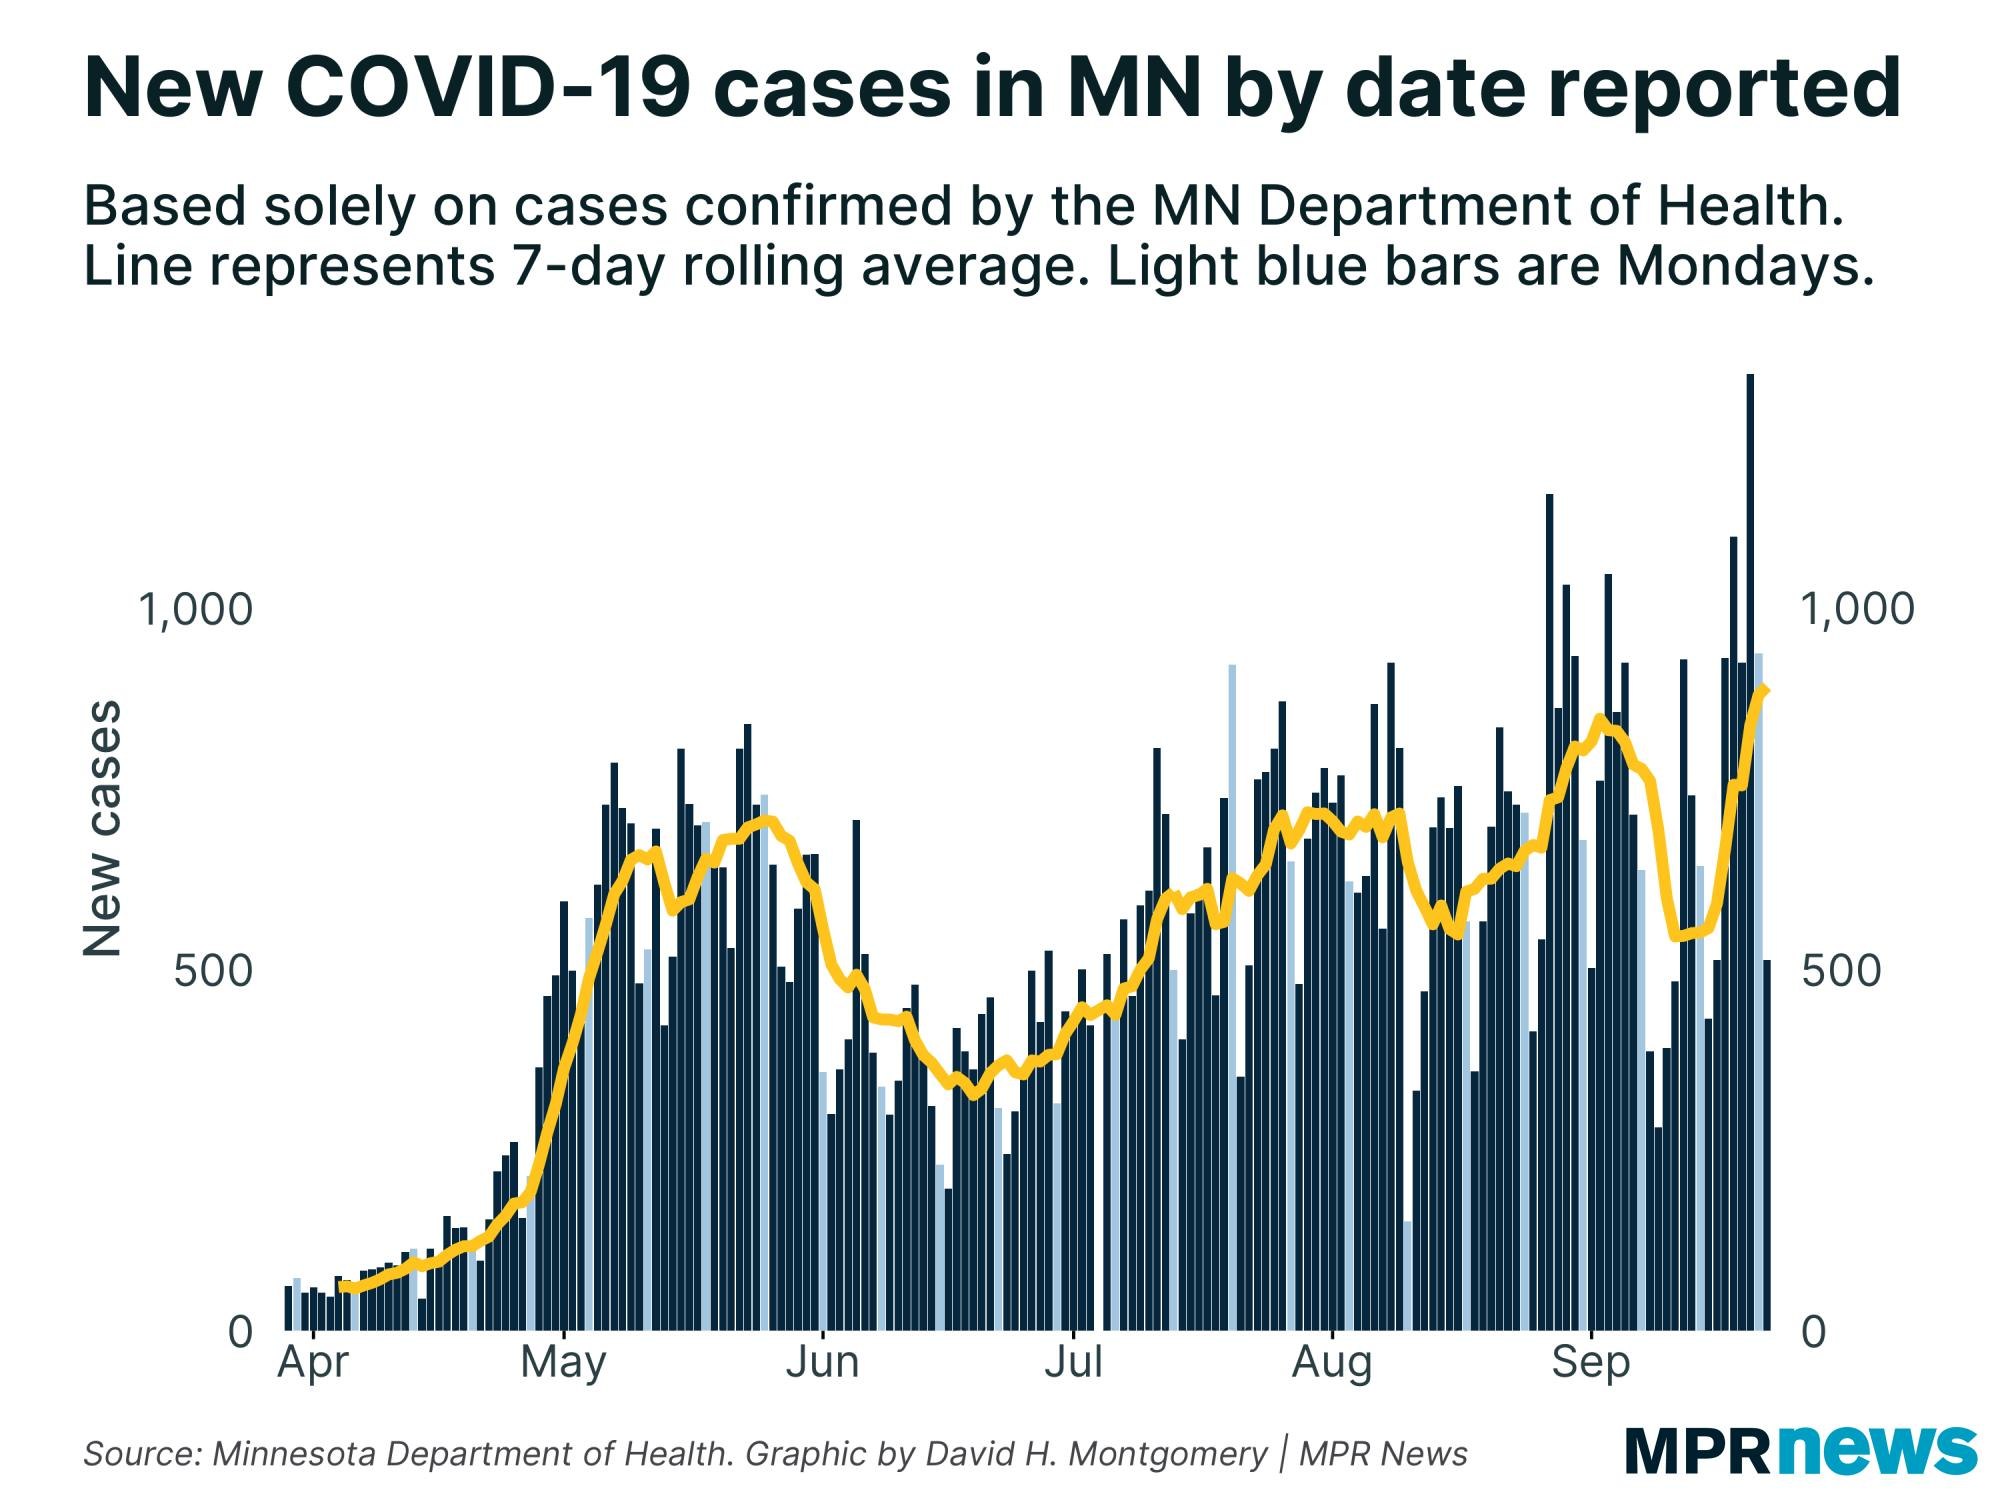Mention a couple of crucial points in this snapshot. The first average count of birds was taken on which date in April? There are 5 Mondays between May and June. The color of the line drawn on the graph is yellow. 